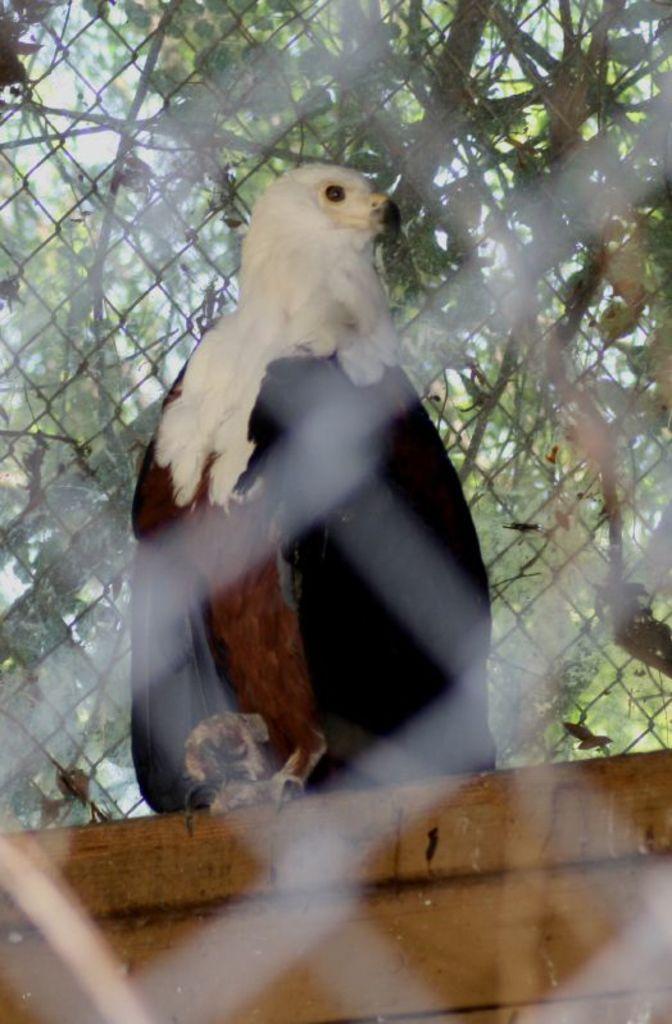In one or two sentences, can you explain what this image depicts? This image consists of a vulture kept on a wooden block. In the background, there are many trees. 